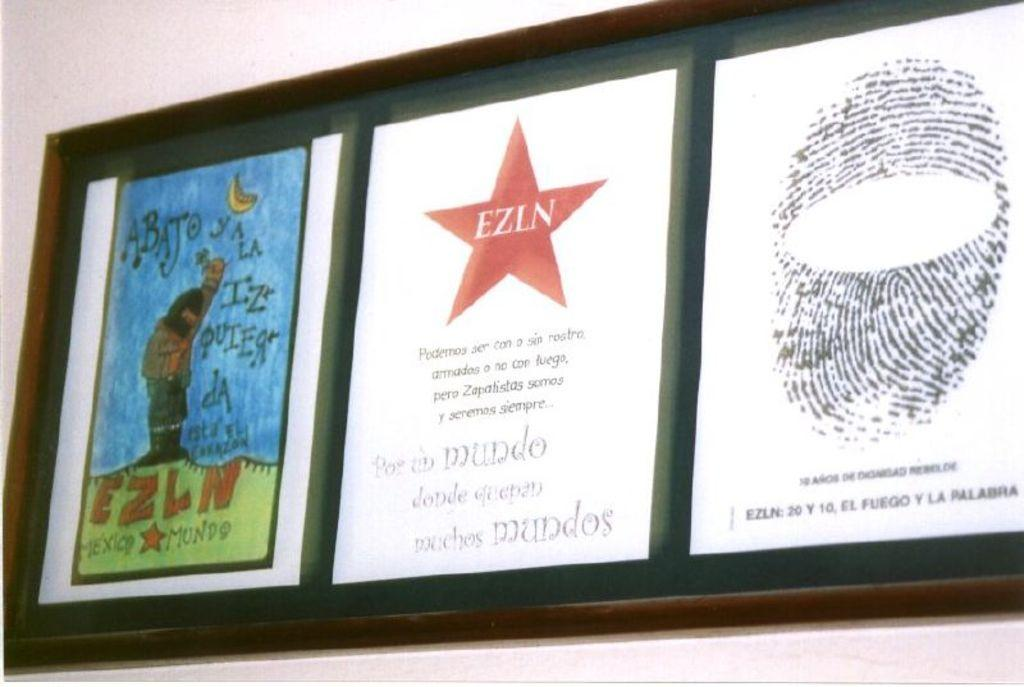<image>
Share a concise interpretation of the image provided. A picture frame with a drawn picture with the words EZLN in a star in the frame 